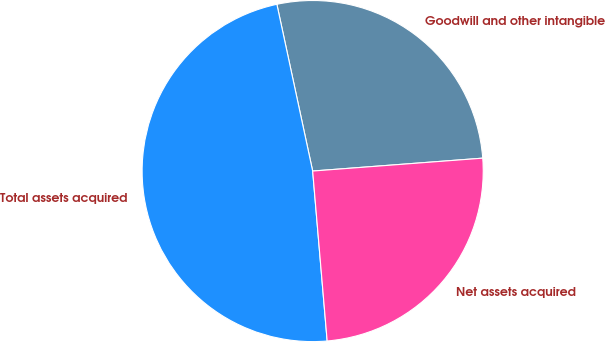Convert chart to OTSL. <chart><loc_0><loc_0><loc_500><loc_500><pie_chart><fcel>Goodwill and other intangible<fcel>Total assets acquired<fcel>Net assets acquired<nl><fcel>27.16%<fcel>47.99%<fcel>24.85%<nl></chart> 